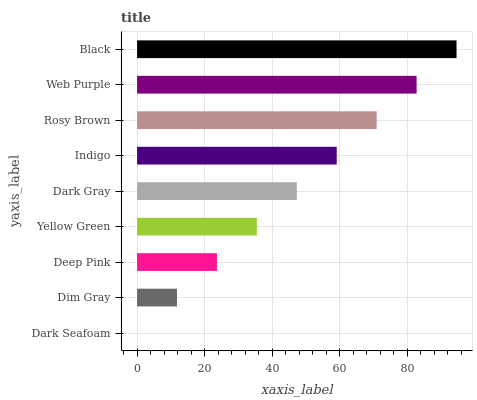Is Dark Seafoam the minimum?
Answer yes or no. Yes. Is Black the maximum?
Answer yes or no. Yes. Is Dim Gray the minimum?
Answer yes or no. No. Is Dim Gray the maximum?
Answer yes or no. No. Is Dim Gray greater than Dark Seafoam?
Answer yes or no. Yes. Is Dark Seafoam less than Dim Gray?
Answer yes or no. Yes. Is Dark Seafoam greater than Dim Gray?
Answer yes or no. No. Is Dim Gray less than Dark Seafoam?
Answer yes or no. No. Is Dark Gray the high median?
Answer yes or no. Yes. Is Dark Gray the low median?
Answer yes or no. Yes. Is Black the high median?
Answer yes or no. No. Is Black the low median?
Answer yes or no. No. 